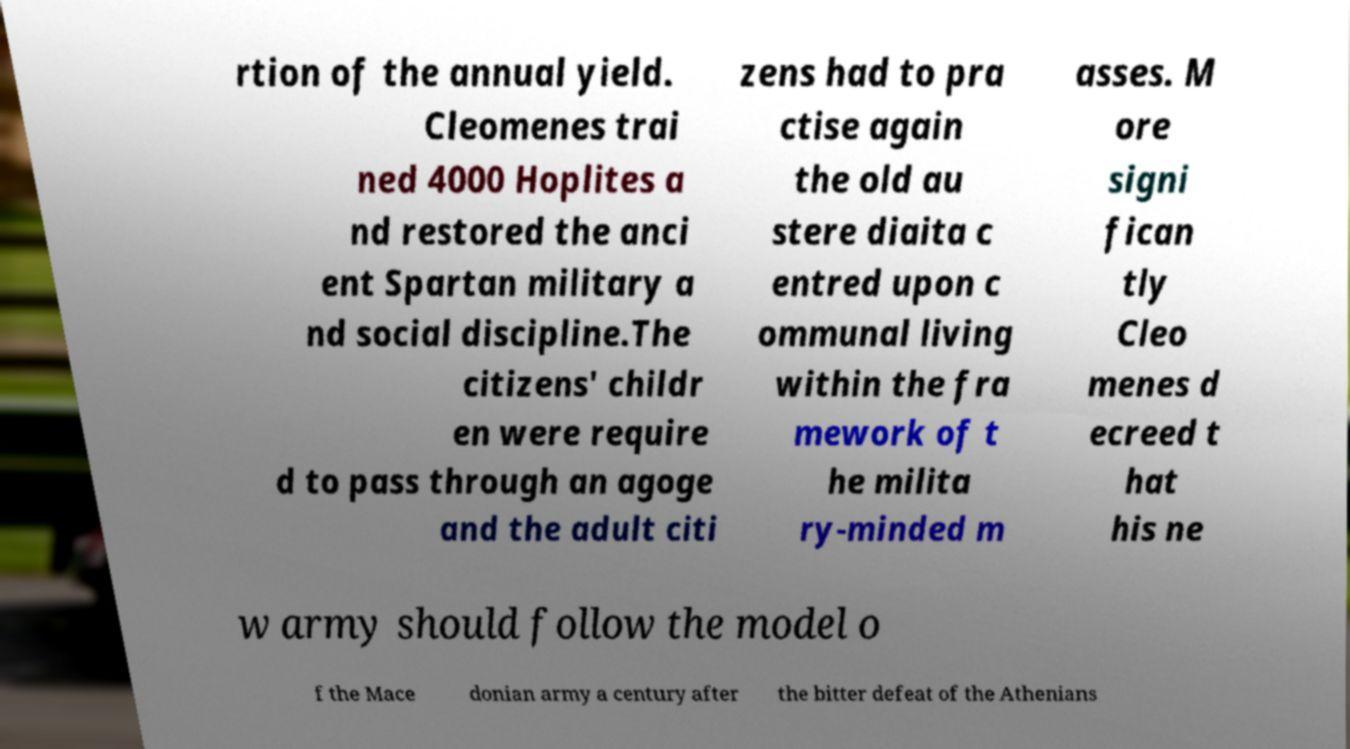Could you extract and type out the text from this image? rtion of the annual yield. Cleomenes trai ned 4000 Hoplites a nd restored the anci ent Spartan military a nd social discipline.The citizens' childr en were require d to pass through an agoge and the adult citi zens had to pra ctise again the old au stere diaita c entred upon c ommunal living within the fra mework of t he milita ry-minded m asses. M ore signi fican tly Cleo menes d ecreed t hat his ne w army should follow the model o f the Mace donian army a century after the bitter defeat of the Athenians 